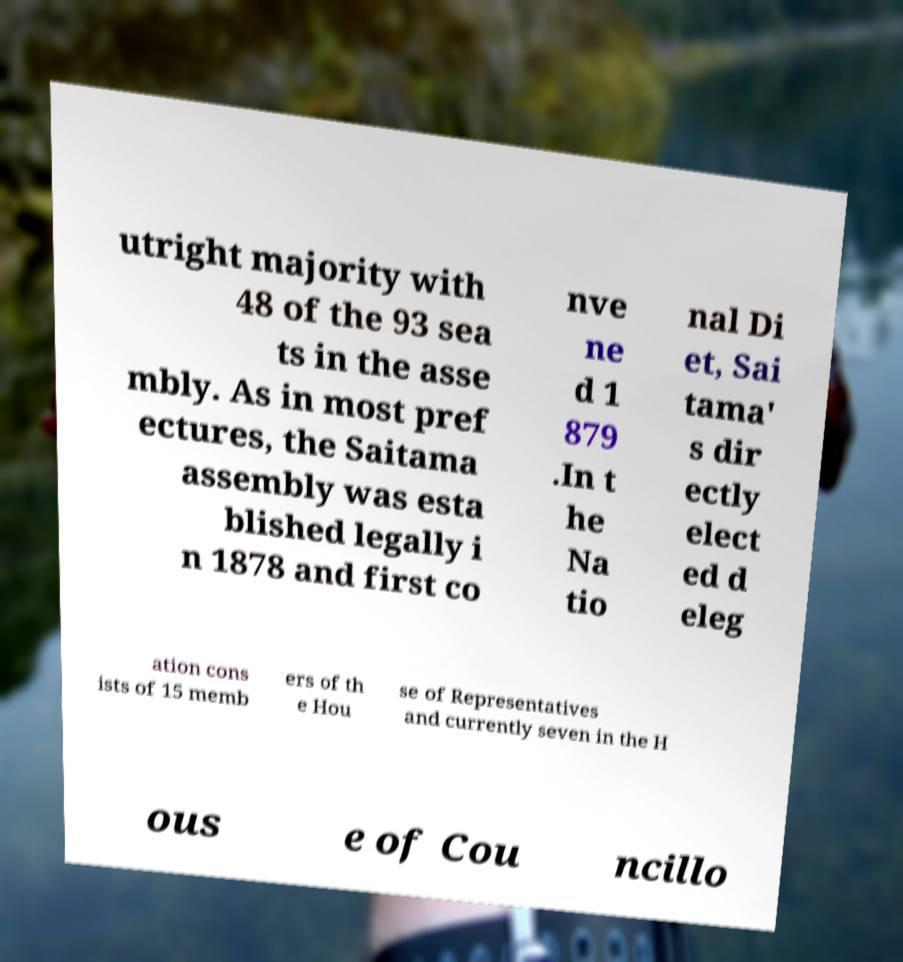There's text embedded in this image that I need extracted. Can you transcribe it verbatim? utright majority with 48 of the 93 sea ts in the asse mbly. As in most pref ectures, the Saitama assembly was esta blished legally i n 1878 and first co nve ne d 1 879 .In t he Na tio nal Di et, Sai tama' s dir ectly elect ed d eleg ation cons ists of 15 memb ers of th e Hou se of Representatives and currently seven in the H ous e of Cou ncillo 